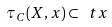<formula> <loc_0><loc_0><loc_500><loc_500>\tau _ { C } ( X , x ) \subset \ t x</formula> 